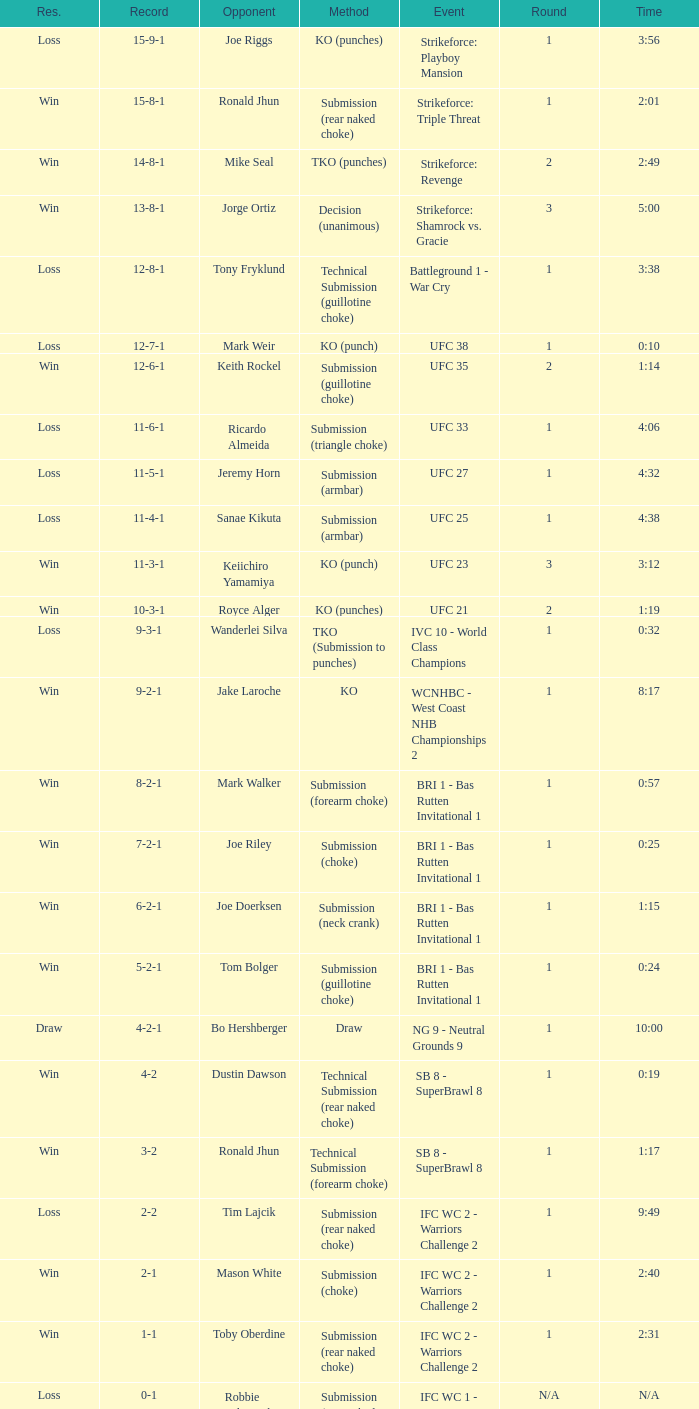What was the outcome when the mode of resolution was knockout? 9-2-1. 